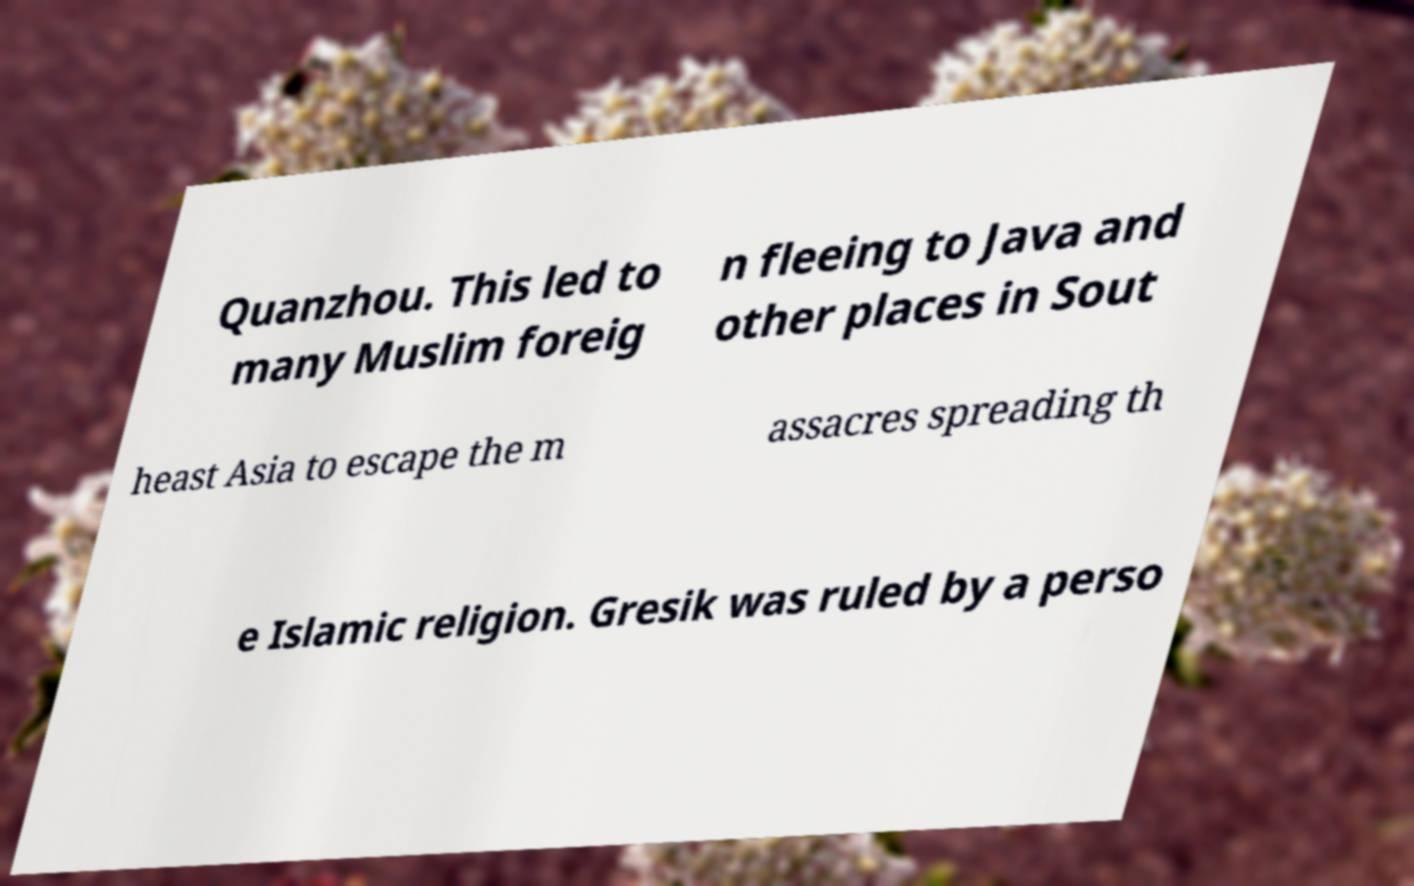Could you assist in decoding the text presented in this image and type it out clearly? Quanzhou. This led to many Muslim foreig n fleeing to Java and other places in Sout heast Asia to escape the m assacres spreading th e Islamic religion. Gresik was ruled by a perso 